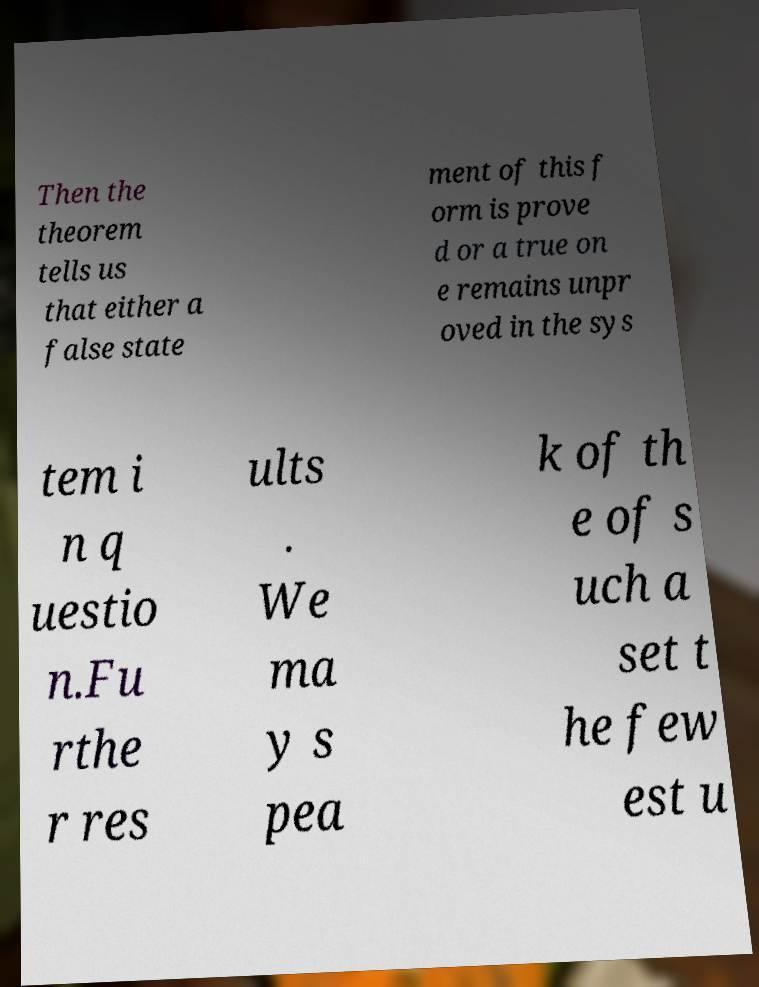Can you accurately transcribe the text from the provided image for me? Then the theorem tells us that either a false state ment of this f orm is prove d or a true on e remains unpr oved in the sys tem i n q uestio n.Fu rthe r res ults . We ma y s pea k of th e of s uch a set t he few est u 